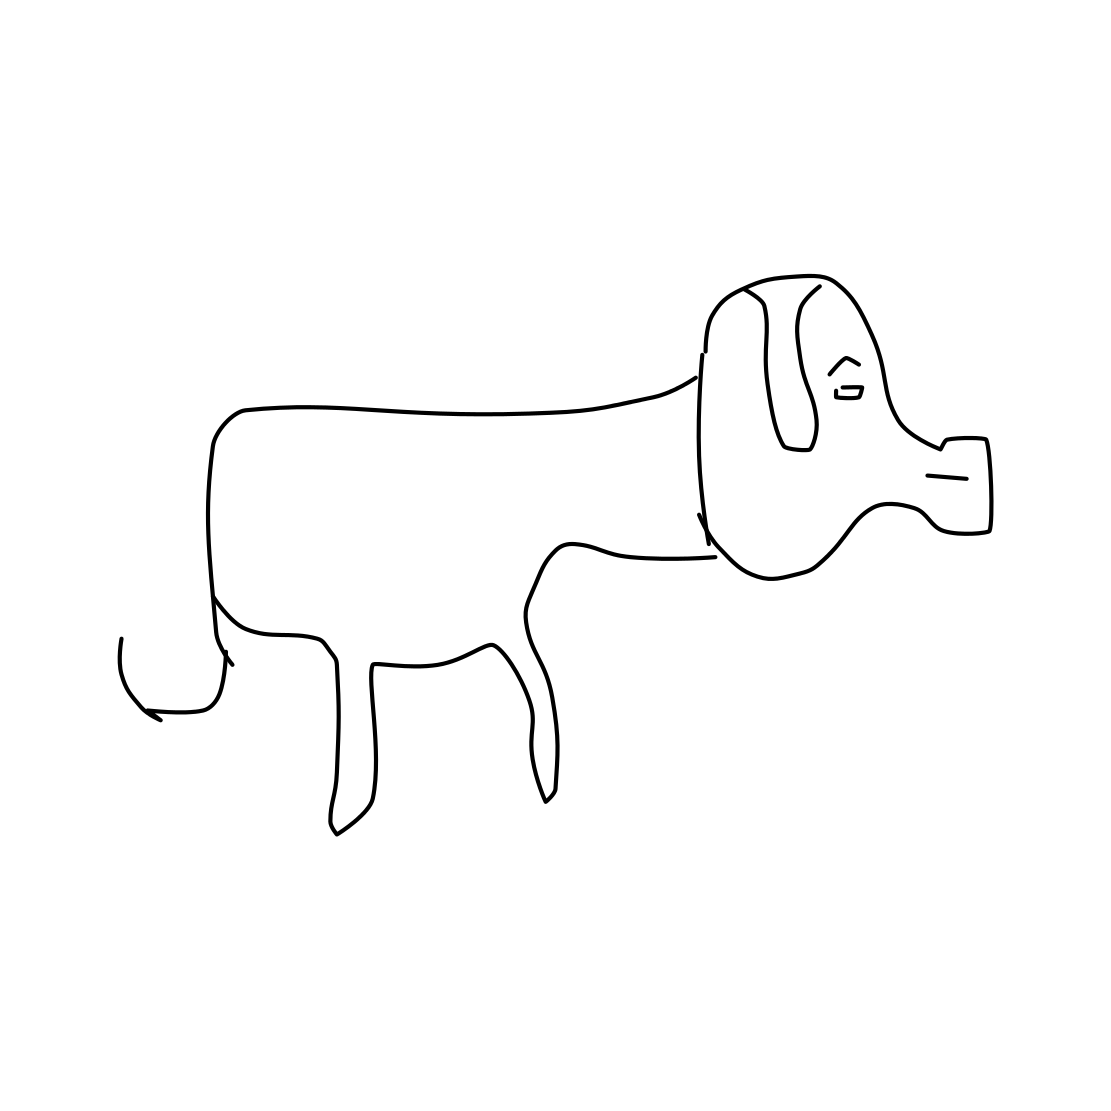Is this a dog in the image? Yes, it is a simple line drawing of a dog. The illustration captures the basic features of a dog, such as its snout, ears, body, and tail, in a minimalistic style. 